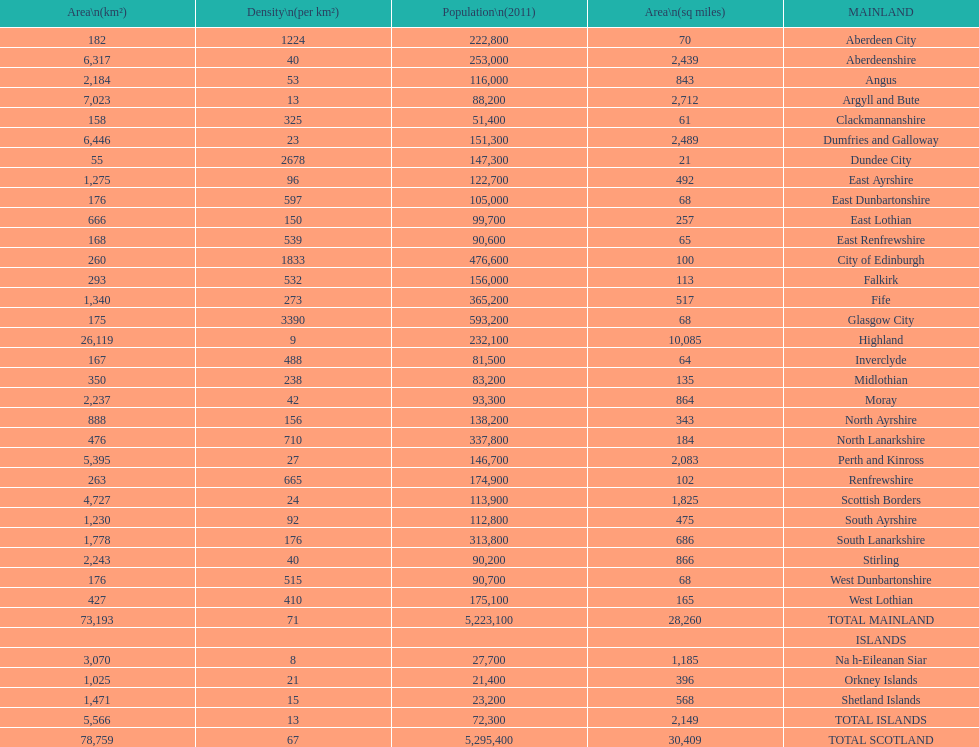I'm looking to parse the entire table for insights. Could you assist me with that? {'header': ['Area\\n(km²)', 'Density\\n(per km²)', 'Population\\n(2011)', 'Area\\n(sq miles)', 'MAINLAND'], 'rows': [['182', '1224', '222,800', '70', 'Aberdeen City'], ['6,317', '40', '253,000', '2,439', 'Aberdeenshire'], ['2,184', '53', '116,000', '843', 'Angus'], ['7,023', '13', '88,200', '2,712', 'Argyll and Bute'], ['158', '325', '51,400', '61', 'Clackmannanshire'], ['6,446', '23', '151,300', '2,489', 'Dumfries and Galloway'], ['55', '2678', '147,300', '21', 'Dundee City'], ['1,275', '96', '122,700', '492', 'East Ayrshire'], ['176', '597', '105,000', '68', 'East Dunbartonshire'], ['666', '150', '99,700', '257', 'East Lothian'], ['168', '539', '90,600', '65', 'East Renfrewshire'], ['260', '1833', '476,600', '100', 'City of Edinburgh'], ['293', '532', '156,000', '113', 'Falkirk'], ['1,340', '273', '365,200', '517', 'Fife'], ['175', '3390', '593,200', '68', 'Glasgow City'], ['26,119', '9', '232,100', '10,085', 'Highland'], ['167', '488', '81,500', '64', 'Inverclyde'], ['350', '238', '83,200', '135', 'Midlothian'], ['2,237', '42', '93,300', '864', 'Moray'], ['888', '156', '138,200', '343', 'North Ayrshire'], ['476', '710', '337,800', '184', 'North Lanarkshire'], ['5,395', '27', '146,700', '2,083', 'Perth and Kinross'], ['263', '665', '174,900', '102', 'Renfrewshire'], ['4,727', '24', '113,900', '1,825', 'Scottish Borders'], ['1,230', '92', '112,800', '475', 'South Ayrshire'], ['1,778', '176', '313,800', '686', 'South Lanarkshire'], ['2,243', '40', '90,200', '866', 'Stirling'], ['176', '515', '90,700', '68', 'West Dunbartonshire'], ['427', '410', '175,100', '165', 'West Lothian'], ['73,193', '71', '5,223,100', '28,260', 'TOTAL MAINLAND'], ['', '', '', '', 'ISLANDS'], ['3,070', '8', '27,700', '1,185', 'Na h-Eileanan Siar'], ['1,025', '21', '21,400', '396', 'Orkney Islands'], ['1,471', '15', '23,200', '568', 'Shetland Islands'], ['5,566', '13', '72,300', '2,149', 'TOTAL ISLANDS'], ['78,759', '67', '5,295,400', '30,409', 'TOTAL SCOTLAND']]} What is the difference in square miles from angus and fife? 326. 